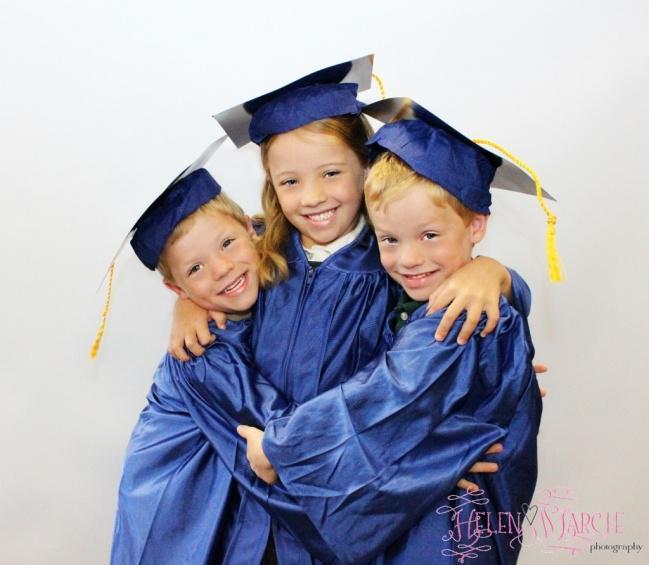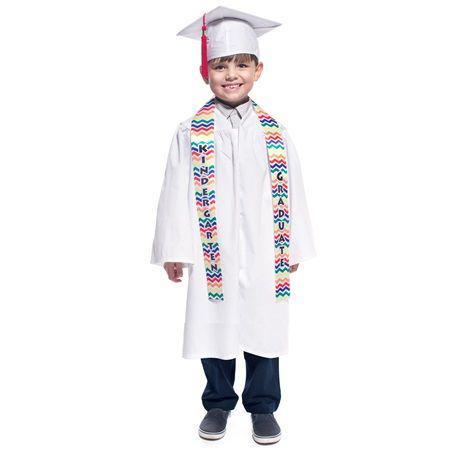The first image is the image on the left, the second image is the image on the right. For the images shown, is this caption "In one of the images there are a pair of students wearing a graduation cap and gown." true? Answer yes or no. No. The first image is the image on the left, the second image is the image on the right. Analyze the images presented: Is the assertion "In each set there are two children in black graduation gowns and caps and one has a yellow collar and one has a red collar." valid? Answer yes or no. No. 